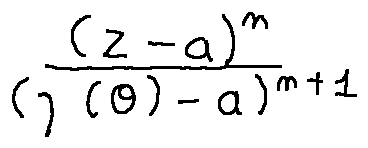<formula> <loc_0><loc_0><loc_500><loc_500>\frac { ( z - a ) ^ { n } } { ( \gamma ( \theta ) - a ) ^ { n + 1 } }</formula> 